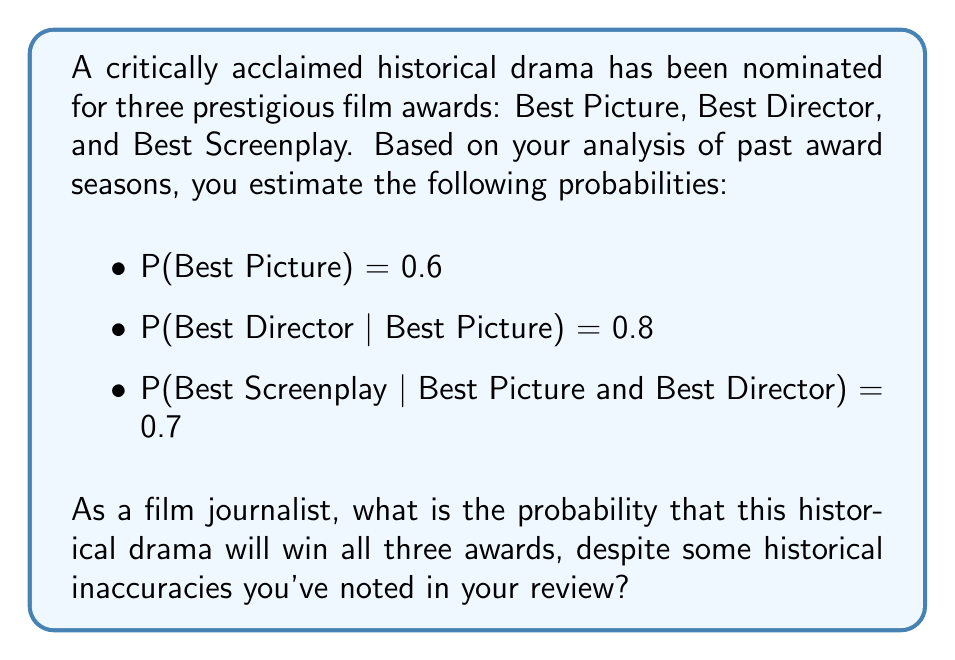Give your solution to this math problem. To solve this problem, we need to use the chain rule of conditional probability. We'll calculate the probability of winning all three awards step by step:

1. First, we need to find P(Best Picture and Best Director):
   $$P(\text{Picture} \cap \text{Director}) = P(\text{Picture}) \cdot P(\text{Director|Picture})$$
   $$P(\text{Picture} \cap \text{Director}) = 0.6 \cdot 0.8 = 0.48$$

2. Now, we can calculate the probability of winning all three awards:
   $$P(\text{Picture} \cap \text{Director} \cap \text{Screenplay}) = P(\text{Picture}) \cdot P(\text{Director|Picture}) \cdot P(\text{Screenplay|Picture} \cap \text{Director})$$
   $$P(\text{Picture} \cap \text{Director} \cap \text{Screenplay}) = 0.6 \cdot 0.8 \cdot 0.7 = 0.336$$

3. Convert the decimal to a percentage:
   $$0.336 \cdot 100\% = 33.6\%$$

Therefore, despite the historical inaccuracies, the film has a 33.6% chance of winning all three awards based on the given probabilities.
Answer: 33.6% 